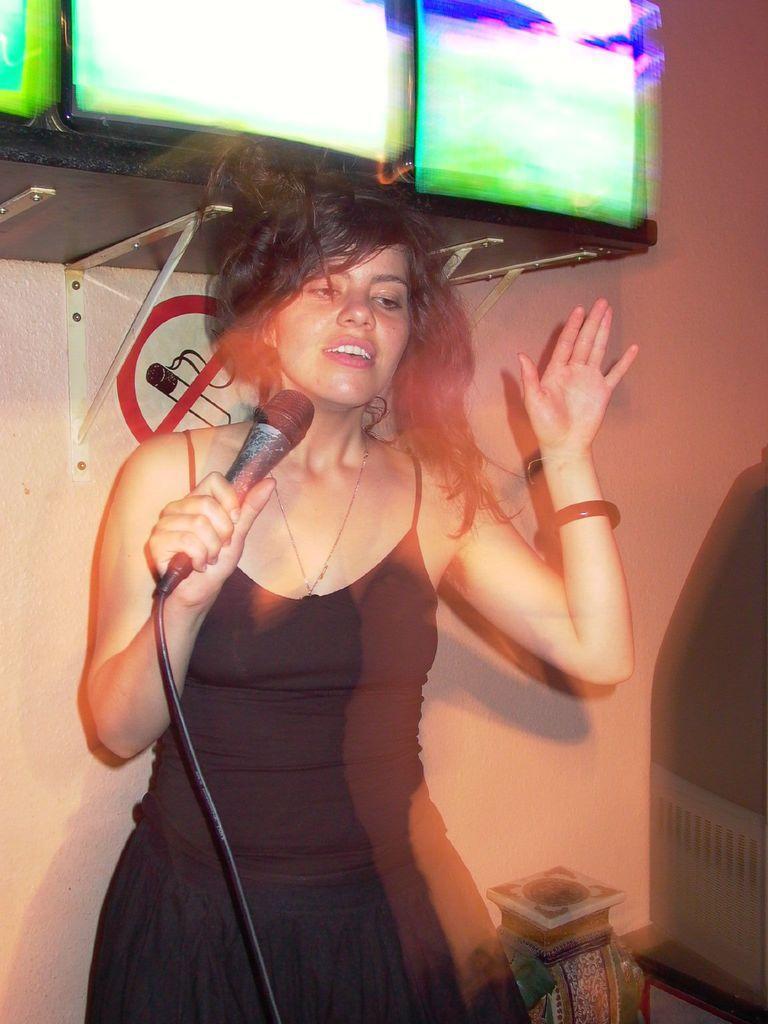Can you describe this image briefly? In this image, we can see holding mic and in the background, we can see screens on the stand and the stand is fixed to a wall and there is a sticker. At the bottom, there are some objects. 